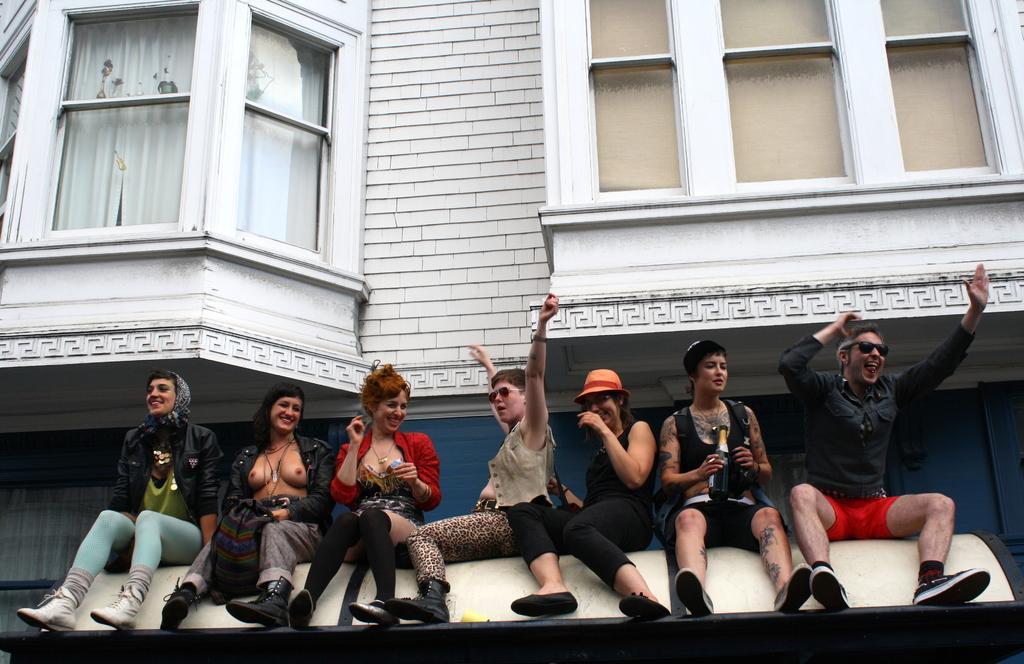How would you summarize this image in a sentence or two? In this image there is a building and we can see windows. At the bottom there are people sitting. The person sitting on the right is holding a bottle. 